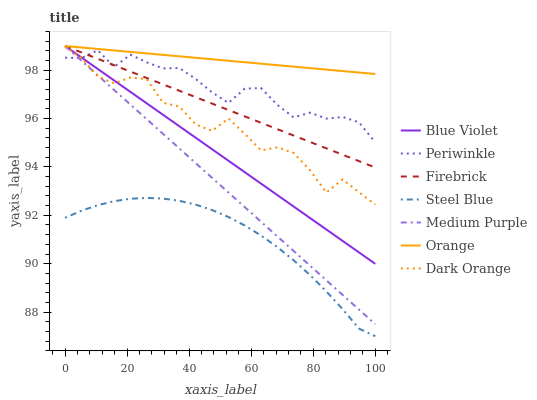Does Steel Blue have the minimum area under the curve?
Answer yes or no. Yes. Does Orange have the maximum area under the curve?
Answer yes or no. Yes. Does Firebrick have the minimum area under the curve?
Answer yes or no. No. Does Firebrick have the maximum area under the curve?
Answer yes or no. No. Is Firebrick the smoothest?
Answer yes or no. Yes. Is Dark Orange the roughest?
Answer yes or no. Yes. Is Steel Blue the smoothest?
Answer yes or no. No. Is Steel Blue the roughest?
Answer yes or no. No. Does Steel Blue have the lowest value?
Answer yes or no. Yes. Does Firebrick have the lowest value?
Answer yes or no. No. Does Blue Violet have the highest value?
Answer yes or no. Yes. Does Steel Blue have the highest value?
Answer yes or no. No. Is Steel Blue less than Medium Purple?
Answer yes or no. Yes. Is Periwinkle greater than Steel Blue?
Answer yes or no. Yes. Does Medium Purple intersect Blue Violet?
Answer yes or no. Yes. Is Medium Purple less than Blue Violet?
Answer yes or no. No. Is Medium Purple greater than Blue Violet?
Answer yes or no. No. Does Steel Blue intersect Medium Purple?
Answer yes or no. No. 